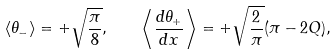<formula> <loc_0><loc_0><loc_500><loc_500>\langle \theta _ { - } \rangle = + \sqrt { \frac { \pi } { 8 } } , \quad \left \langle \frac { d \theta _ { + } } { d x } \right \rangle = + \sqrt { \frac { 2 } { \pi } } ( \pi - 2 Q ) ,</formula> 